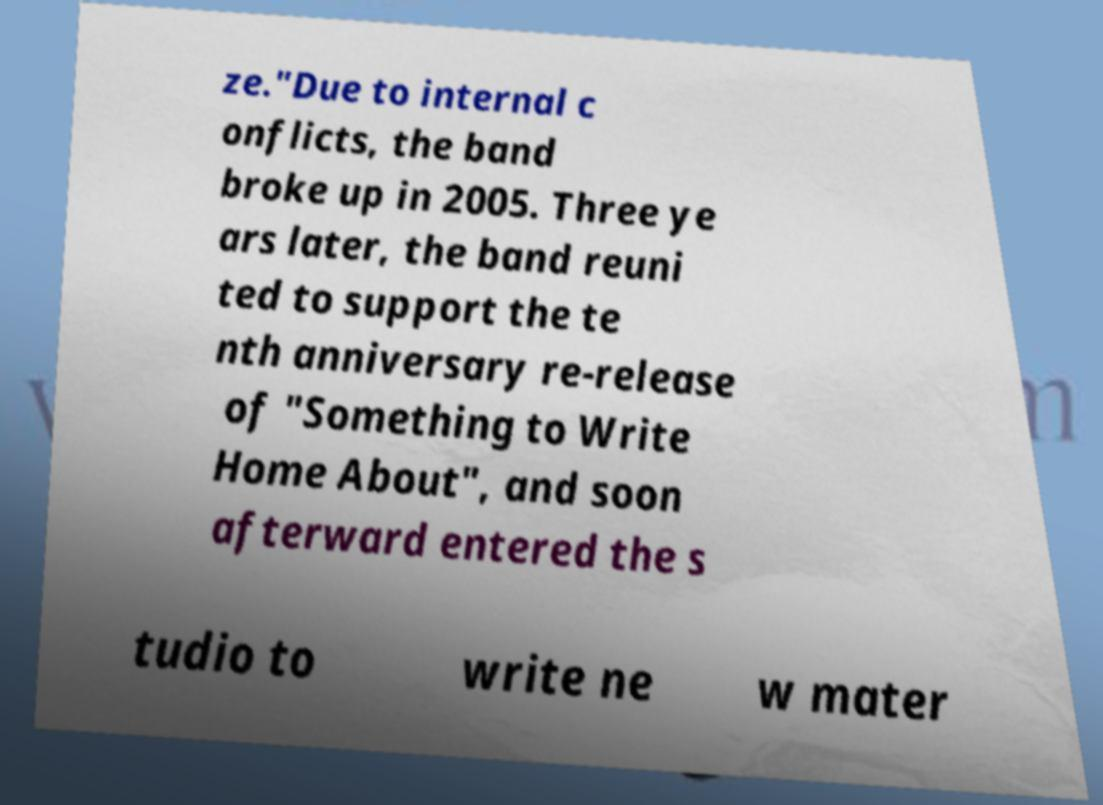What messages or text are displayed in this image? I need them in a readable, typed format. ze."Due to internal c onflicts, the band broke up in 2005. Three ye ars later, the band reuni ted to support the te nth anniversary re-release of "Something to Write Home About", and soon afterward entered the s tudio to write ne w mater 